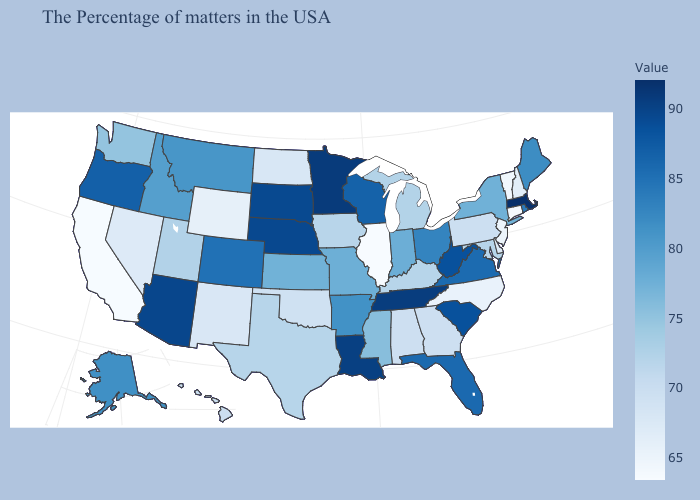Does Illinois have the lowest value in the USA?
Give a very brief answer. Yes. Does Massachusetts have the highest value in the USA?
Write a very short answer. Yes. Which states have the highest value in the USA?
Write a very short answer. Massachusetts. Among the states that border Illinois , does Iowa have the highest value?
Write a very short answer. No. Does Massachusetts have the highest value in the USA?
Answer briefly. Yes. Does Vermont have the lowest value in the Northeast?
Give a very brief answer. No. Which states have the lowest value in the West?
Concise answer only. California. Does the map have missing data?
Concise answer only. No. 